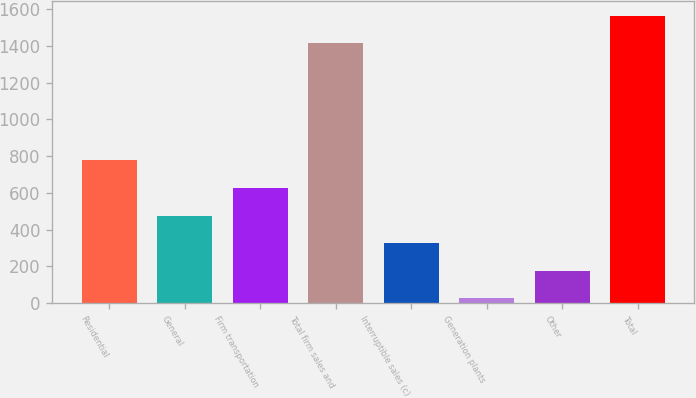Convert chart. <chart><loc_0><loc_0><loc_500><loc_500><bar_chart><fcel>Residential<fcel>General<fcel>Firm transportation<fcel>Total firm sales and<fcel>Interruptible sales (c)<fcel>Generation plants<fcel>Other<fcel>Total<nl><fcel>776.5<fcel>476.3<fcel>626.4<fcel>1414<fcel>326.2<fcel>26<fcel>176.1<fcel>1564.1<nl></chart> 